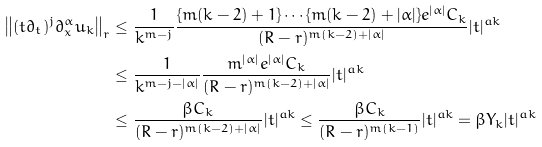Convert formula to latex. <formula><loc_0><loc_0><loc_500><loc_500>\left \| ( t \partial _ { t } ) ^ { j } \partial _ { x } ^ { \alpha } u _ { k } \right \| _ { r } & \leq \frac { 1 } { k ^ { m - j } } \frac { \{ m ( k - 2 ) + 1 \} \cdots \{ m ( k - 2 ) + | \alpha | \} e ^ { | \alpha | } C _ { k } } { ( R - r ) ^ { m ( k - 2 ) + | \alpha | } } | t | ^ { a k } \\ & \leq \frac { 1 } { k ^ { m - j - | \alpha | } } \frac { m ^ { | \alpha | } e ^ { | \alpha | } C _ { k } } { ( R - r ) ^ { m ( k - 2 ) + | \alpha | } } | t | ^ { a k } \\ & \leq \frac { \beta C _ { k } } { ( R - r ) ^ { m ( k - 2 ) + | \alpha | } } | t | ^ { a k } \leq \frac { \beta C _ { k } } { ( R - r ) ^ { m ( k - 1 ) } } | t | ^ { a k } = \beta Y _ { k } | t | ^ { a k }</formula> 